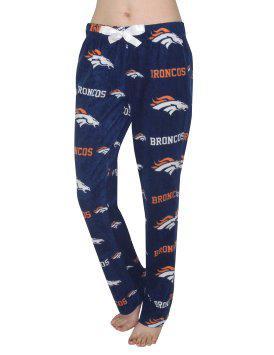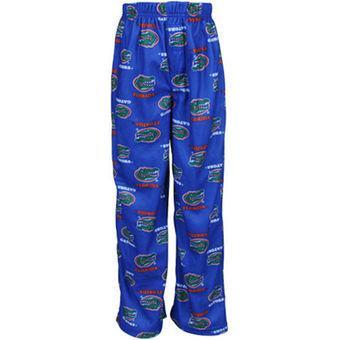The first image is the image on the left, the second image is the image on the right. For the images displayed, is the sentence "at least one pair of pants is worn by a human." factually correct? Answer yes or no. Yes. 